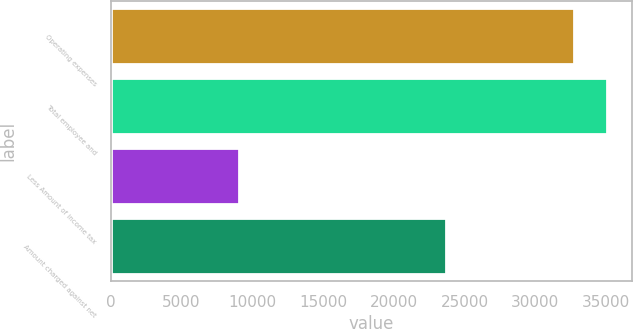<chart> <loc_0><loc_0><loc_500><loc_500><bar_chart><fcel>Operating expenses<fcel>Total employee and<fcel>Less Amount of income tax<fcel>Amount charged against net<nl><fcel>32719<fcel>35085.1<fcel>9058<fcel>23661<nl></chart> 